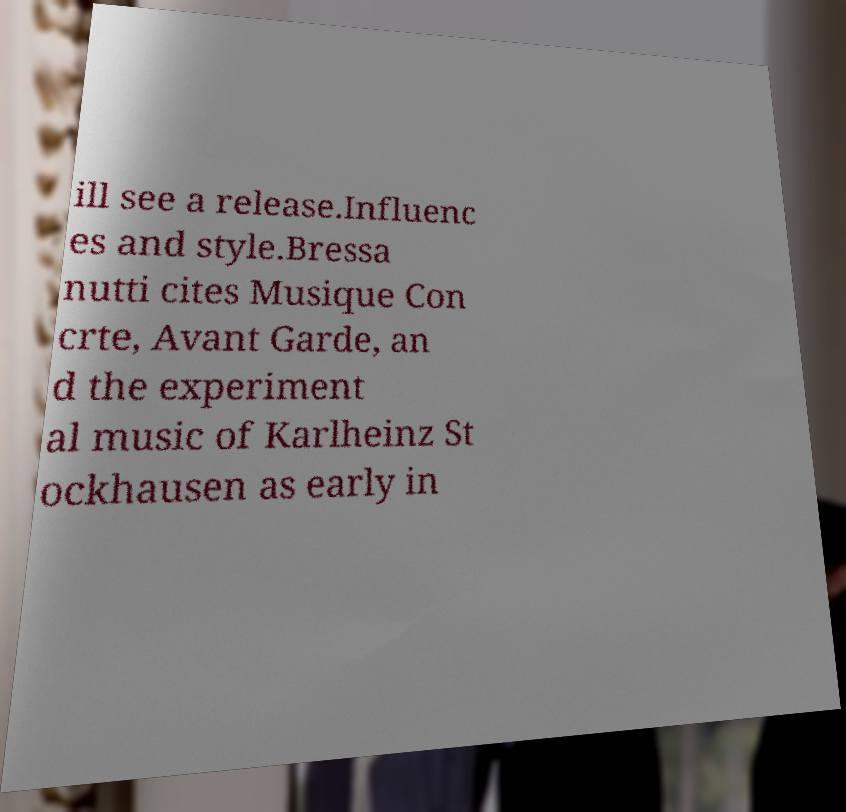Can you read and provide the text displayed in the image?This photo seems to have some interesting text. Can you extract and type it out for me? ill see a release.Influenc es and style.Bressa nutti cites Musique Con crte, Avant Garde, an d the experiment al music of Karlheinz St ockhausen as early in 